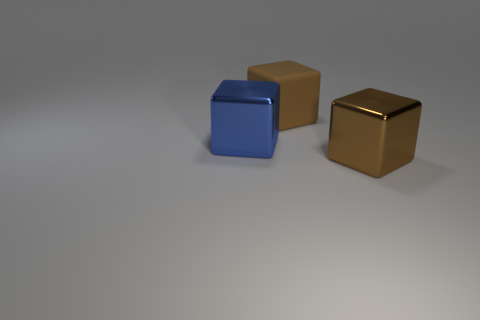Add 1 blue shiny blocks. How many objects exist? 4 Add 3 matte things. How many matte things are left? 4 Add 1 big metallic things. How many big metallic things exist? 3 Subtract 0 yellow spheres. How many objects are left? 3 Subtract all green cubes. Subtract all big brown rubber blocks. How many objects are left? 2 